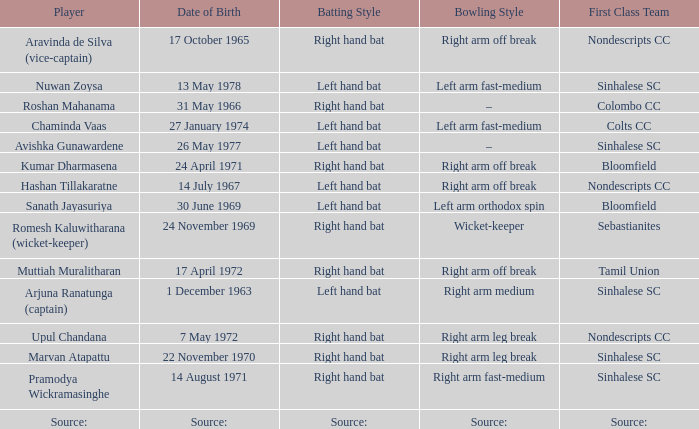When was roshan mahanama born? 31 May 1966. 